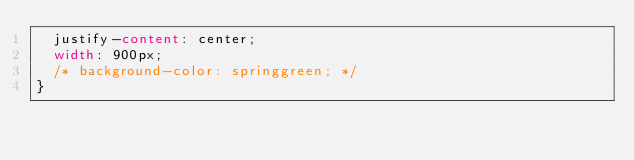Convert code to text. <code><loc_0><loc_0><loc_500><loc_500><_CSS_>  justify-content: center;
  width: 900px;
  /* background-color: springgreen; */
}
</code> 